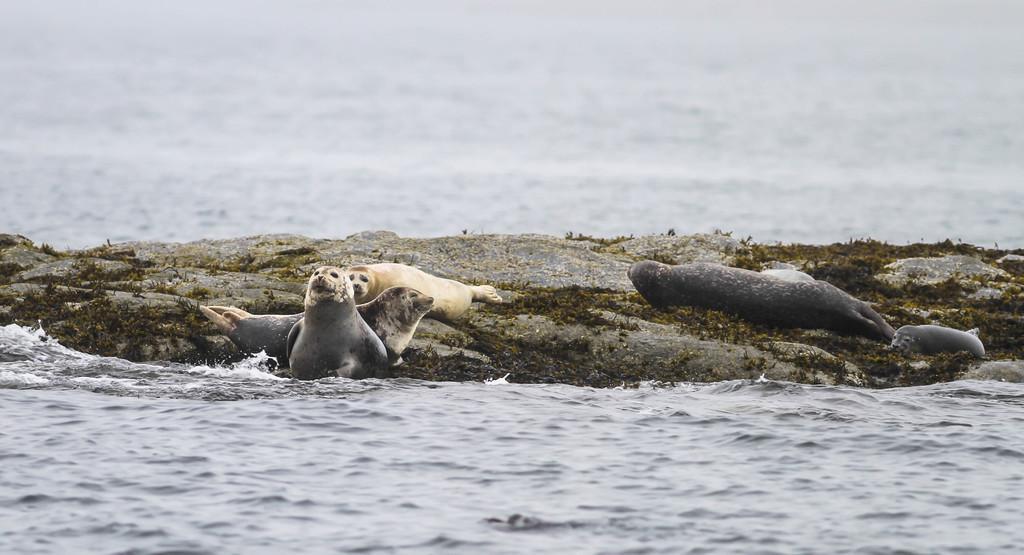Please provide a concise description of this image. In this picture there is a water body. In the center of the picture there are seals, grass and land. 